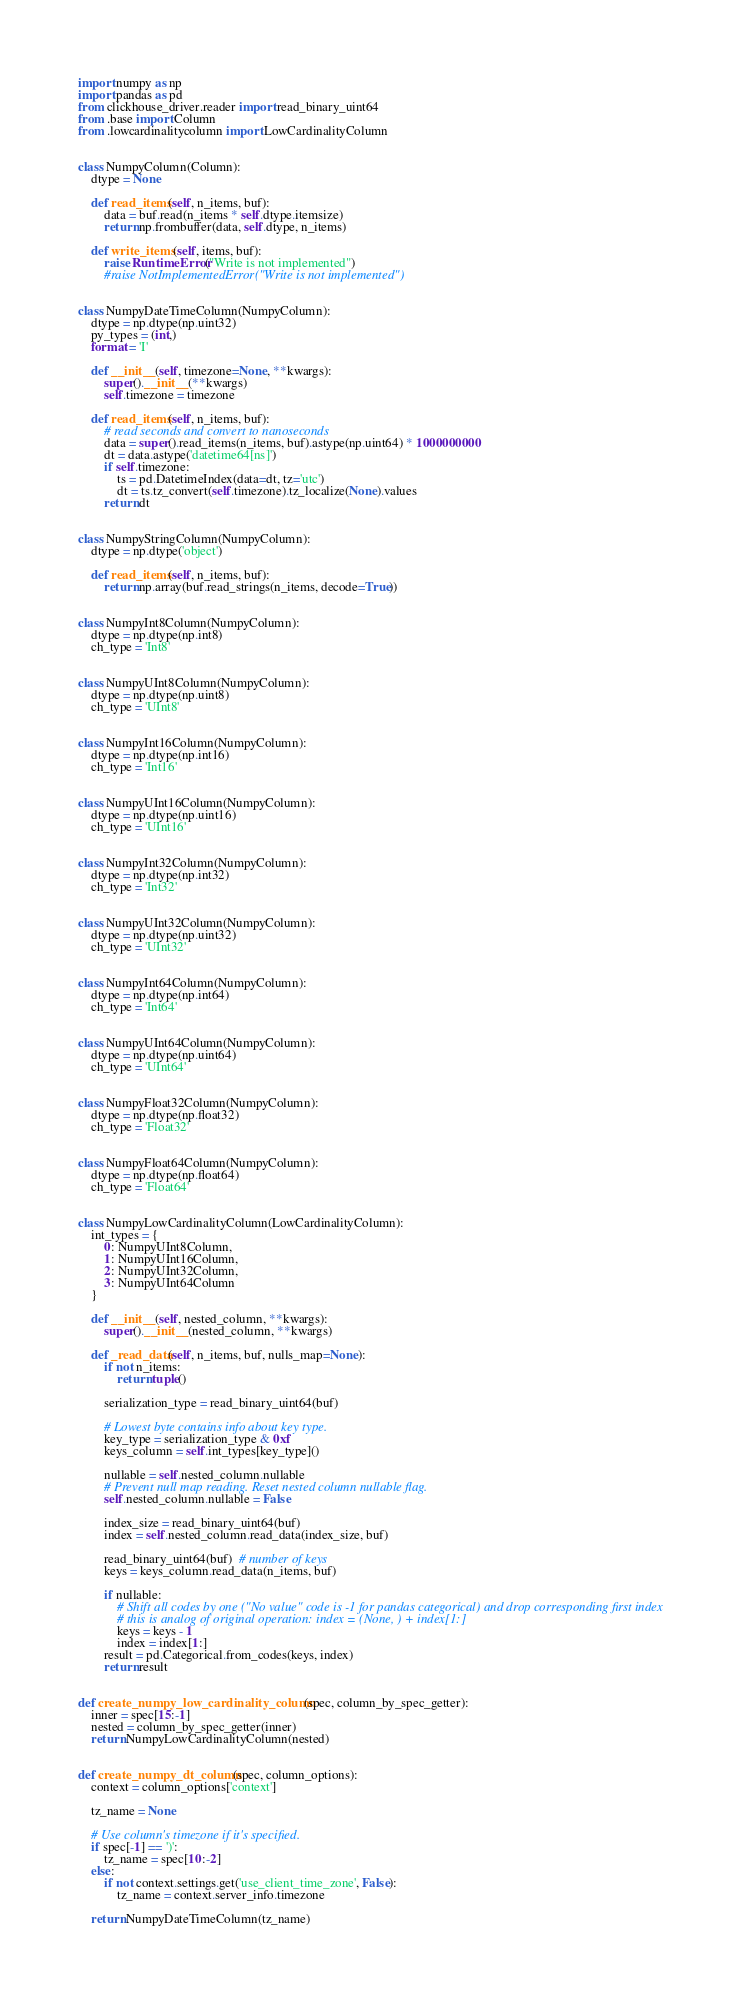<code> <loc_0><loc_0><loc_500><loc_500><_Python_>import numpy as np
import pandas as pd
from clickhouse_driver.reader import read_binary_uint64
from .base import Column
from .lowcardinalitycolumn import LowCardinalityColumn


class NumpyColumn(Column):
    dtype = None

    def read_items(self, n_items, buf):
        data = buf.read(n_items * self.dtype.itemsize)
        return np.frombuffer(data, self.dtype, n_items)

    def write_items(self, items, buf):
        raise RuntimeError("Write is not implemented")
        #raise NotImplementedError("Write is not implemented")


class NumpyDateTimeColumn(NumpyColumn):
    dtype = np.dtype(np.uint32)
    py_types = (int,)
    format = 'I'

    def __init__(self, timezone=None, **kwargs):
        super().__init__(**kwargs)
        self.timezone = timezone

    def read_items(self, n_items, buf):
        # read seconds and convert to nanoseconds
        data = super().read_items(n_items, buf).astype(np.uint64) * 1000000000
        dt = data.astype('datetime64[ns]')
        if self.timezone:
            ts = pd.DatetimeIndex(data=dt, tz='utc')
            dt = ts.tz_convert(self.timezone).tz_localize(None).values
        return dt


class NumpyStringColumn(NumpyColumn):
    dtype = np.dtype('object')

    def read_items(self, n_items, buf):
        return np.array(buf.read_strings(n_items, decode=True))


class NumpyInt8Column(NumpyColumn):
    dtype = np.dtype(np.int8)
    ch_type = 'Int8'


class NumpyUInt8Column(NumpyColumn):
    dtype = np.dtype(np.uint8)
    ch_type = 'UInt8'


class NumpyInt16Column(NumpyColumn):
    dtype = np.dtype(np.int16)
    ch_type = 'Int16'


class NumpyUInt16Column(NumpyColumn):
    dtype = np.dtype(np.uint16)
    ch_type = 'UInt16'


class NumpyInt32Column(NumpyColumn):
    dtype = np.dtype(np.int32)
    ch_type = 'Int32'


class NumpyUInt32Column(NumpyColumn):
    dtype = np.dtype(np.uint32)
    ch_type = 'UInt32'


class NumpyInt64Column(NumpyColumn):
    dtype = np.dtype(np.int64)
    ch_type = 'Int64'


class NumpyUInt64Column(NumpyColumn):
    dtype = np.dtype(np.uint64)
    ch_type = 'UInt64'


class NumpyFloat32Column(NumpyColumn):
    dtype = np.dtype(np.float32)
    ch_type = 'Float32'


class NumpyFloat64Column(NumpyColumn):
    dtype = np.dtype(np.float64)
    ch_type = 'Float64'


class NumpyLowCardinalityColumn(LowCardinalityColumn):
    int_types = {
        0: NumpyUInt8Column,
        1: NumpyUInt16Column,
        2: NumpyUInt32Column,
        3: NumpyUInt64Column
    }

    def __init__(self, nested_column, **kwargs):
        super().__init__(nested_column, **kwargs)

    def _read_data(self, n_items, buf, nulls_map=None):
        if not n_items:
            return tuple()

        serialization_type = read_binary_uint64(buf)

        # Lowest byte contains info about key type.
        key_type = serialization_type & 0xf
        keys_column = self.int_types[key_type]()

        nullable = self.nested_column.nullable
        # Prevent null map reading. Reset nested column nullable flag.
        self.nested_column.nullable = False

        index_size = read_binary_uint64(buf)
        index = self.nested_column.read_data(index_size, buf)

        read_binary_uint64(buf)  # number of keys
        keys = keys_column.read_data(n_items, buf)

        if nullable:
            # Shift all codes by one ("No value" code is -1 for pandas categorical) and drop corresponding first index
            # this is analog of original operation: index = (None, ) + index[1:]
            keys = keys - 1
            index = index[1:]
        result = pd.Categorical.from_codes(keys, index)
        return result


def create_numpy_low_cardinality_column(spec, column_by_spec_getter):
    inner = spec[15:-1]
    nested = column_by_spec_getter(inner)
    return NumpyLowCardinalityColumn(nested)


def create_numpy_dt_column(spec, column_options):
    context = column_options['context']

    tz_name = None

    # Use column's timezone if it's specified.
    if spec[-1] == ')':
        tz_name = spec[10:-2]
    else:
        if not context.settings.get('use_client_time_zone', False):
            tz_name = context.server_info.timezone

    return NumpyDateTimeColumn(tz_name)
</code> 